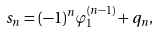Convert formula to latex. <formula><loc_0><loc_0><loc_500><loc_500>s _ { n } = ( - 1 ) ^ { n } \varphi _ { 1 } ^ { ( n - 1 ) } + q _ { n } ,</formula> 